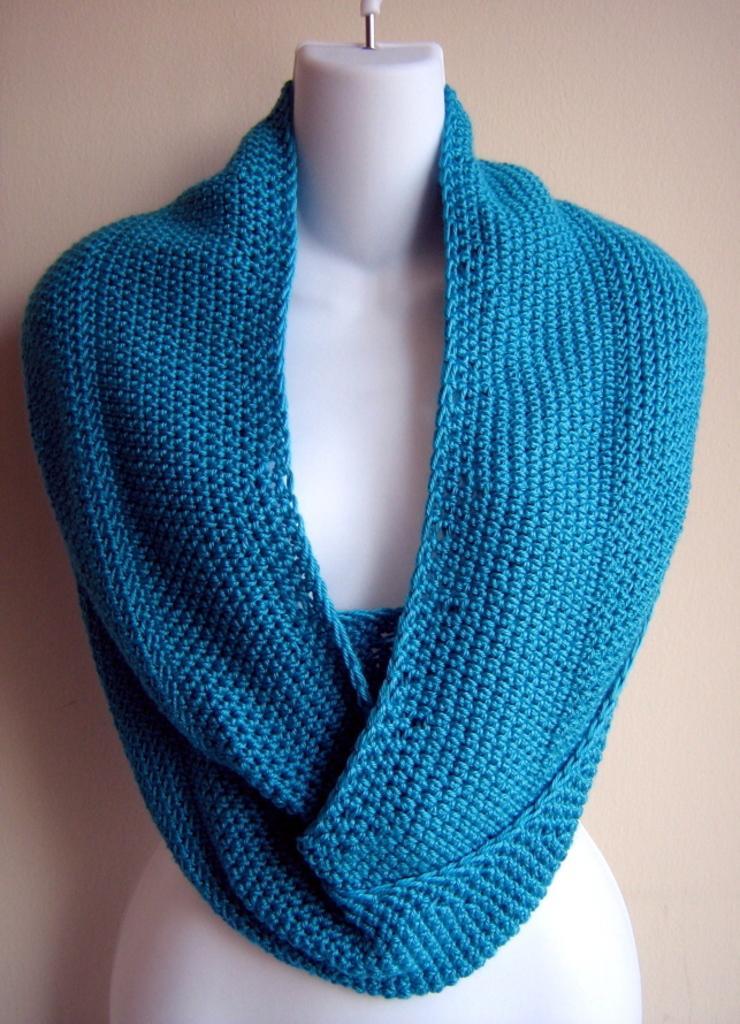Describe this image in one or two sentences. In this image we can see a cloth to the mannequin. 